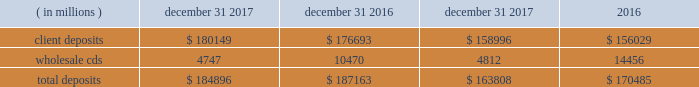Management 2019s discussion and analysis of financial condition and results of operations state street corporation | 90 table 30 : total deposits average balance december 31 years ended december 31 .
Short-term funding our on-balance sheet liquid assets are also an integral component of our liquidity management strategy .
These assets provide liquidity through maturities of the assets , but more importantly , they provide us with the ability to raise funds by pledging the securities as collateral for borrowings or through outright sales .
In addition , our access to the global capital markets gives us the ability to source incremental funding at reasonable rates of interest from wholesale investors .
As discussed earlier under 201casset liquidity , 201d state street bank's membership in the fhlb allows for advances of liquidity with varying terms against high-quality collateral .
Short-term secured funding also comes in the form of securities lent or sold under agreements to repurchase .
These transactions are short-term in nature , generally overnight , and are collateralized by high-quality investment securities .
These balances were $ 2.84 billion and $ 4.40 billion as of december 31 , 2017 and december 31 , 2016 , respectively .
State street bank currently maintains a line of credit with a financial institution of cad 1.40 billion , or approximately $ 1.11 billion as of december 31 , 2017 , to support its canadian securities processing operations .
The line of credit has no stated termination date and is cancelable by either party with prior notice .
As of december 31 , 2017 , there was no balance outstanding on this line of credit .
Long-term funding we have the ability to issue debt and equity securities under our current universal shelf registration to meet current commitments and business needs , including accommodating the transaction and cash management needs of our clients .
In addition , state street bank , a wholly owned subsidiary of the parent company , also has authorization to issue up to $ 5 billion in unsecured senior debt and an additional $ 500 million of subordinated debt .
Agency credit ratings our ability to maintain consistent access to liquidity is fostered by the maintenance of high investment-grade ratings as measured by the major independent credit rating agencies .
Factors essential to maintaining high credit ratings include : 2022 diverse and stable core earnings ; 2022 relative market position ; 2022 strong risk management ; 2022 strong capital ratios ; 2022 diverse liquidity sources , including the global capital markets and client deposits ; 2022 strong liquidity monitoring procedures ; and 2022 preparedness for current or future regulatory developments .
High ratings limit borrowing costs and enhance our liquidity by : 2022 providing assurance for unsecured funding and depositors ; 2022 increasing the potential market for our debt and improving our ability to offer products ; 2022 serving markets ; and 2022 engaging in transactions in which clients value high credit ratings .
A downgrade or reduction of our credit ratings could have a material adverse effect on our liquidity by restricting our ability to access the capital markets , which could increase the related cost of funds .
In turn , this could cause the sudden and large-scale withdrawal of unsecured deposits by our clients , which could lead to draw-downs of unfunded commitments to extend credit or trigger requirements under securities purchase commitments ; or require additional collateral or force terminations of certain trading derivative contracts .
A majority of our derivative contracts have been entered into under bilateral agreements with counterparties who may require us to post collateral or terminate the transactions based on changes in our credit ratings .
We assess the impact of these arrangements by determining the collateral that would be required assuming a downgrade by all rating agencies .
The additional collateral or termination payments related to our net derivative liabilities under these arrangements that could have been called by counterparties in the event of a downgrade in our credit ratings below levels specified in the agreements is disclosed in note 10 to the consolidated financial statements included under item 8 , financial statements and supplementary data , of this form 10-k .
Other funding sources , such as secured financing transactions and other margin requirements , for which there are no explicit triggers , could also be adversely affected. .
What is the percentage change in client deposits from 2017 to 2018? 
Computations: ((180149 - 176693) / 176693)
Answer: 0.01956. 